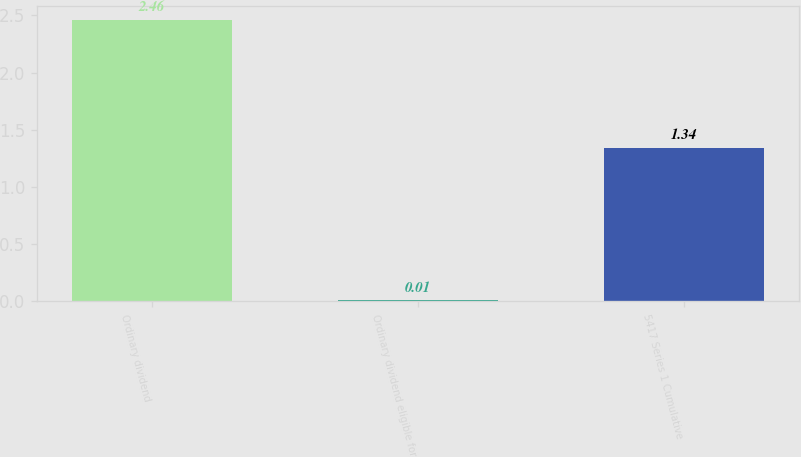<chart> <loc_0><loc_0><loc_500><loc_500><bar_chart><fcel>Ordinary dividend<fcel>Ordinary dividend eligible for<fcel>5417 Series 1 Cumulative<nl><fcel>2.46<fcel>0.01<fcel>1.34<nl></chart> 